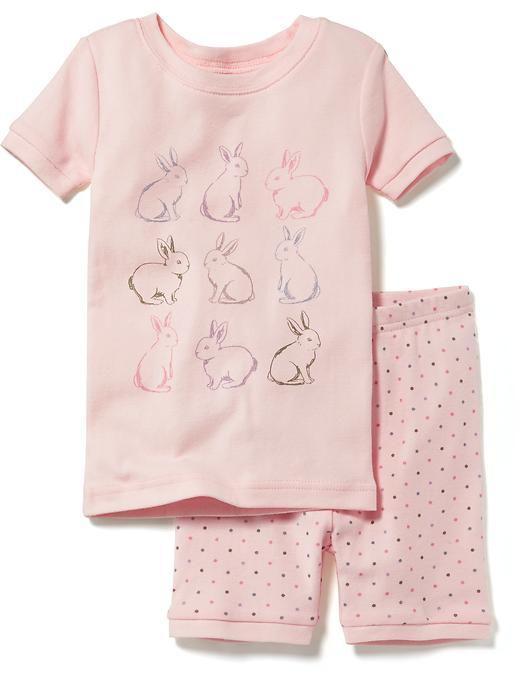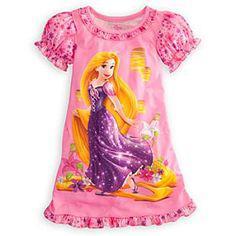The first image is the image on the left, the second image is the image on the right. Given the left and right images, does the statement "There are two outfits in one of the images." hold true? Answer yes or no. No. The first image is the image on the left, the second image is the image on the right. Given the left and right images, does the statement "Sleepwear on the right features a Disney Princess theme on the front." hold true? Answer yes or no. Yes. 